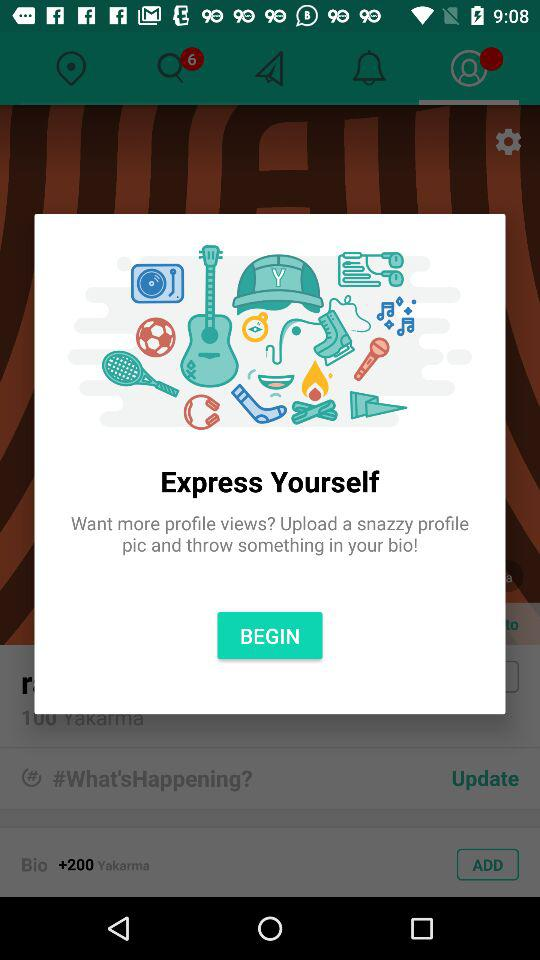How many unread notifications are there? There are 6 unread notifications. 